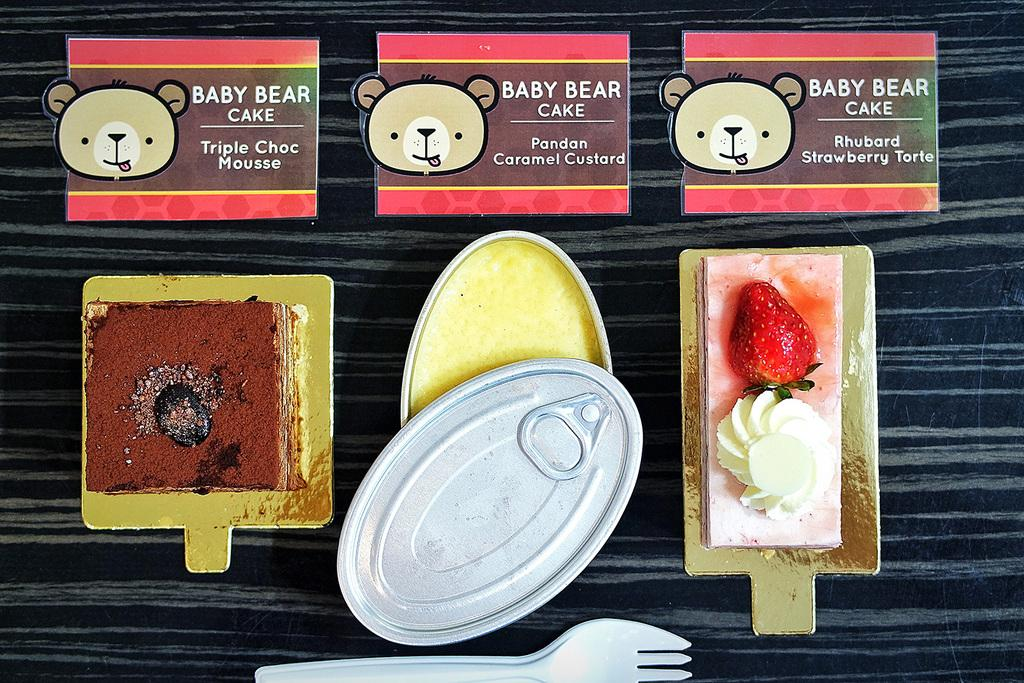What types of food items can be seen in the image? There are three different kinds of food items in the image. How can you identify each food item? Each food item has a label on top of it. What utensil is visible at the bottom of the image? There is a fork at the bottom of the image. What type of engine is powering the food items in the image? There is no engine present in the image, as the food items are stationary and not powered by any machinery. 